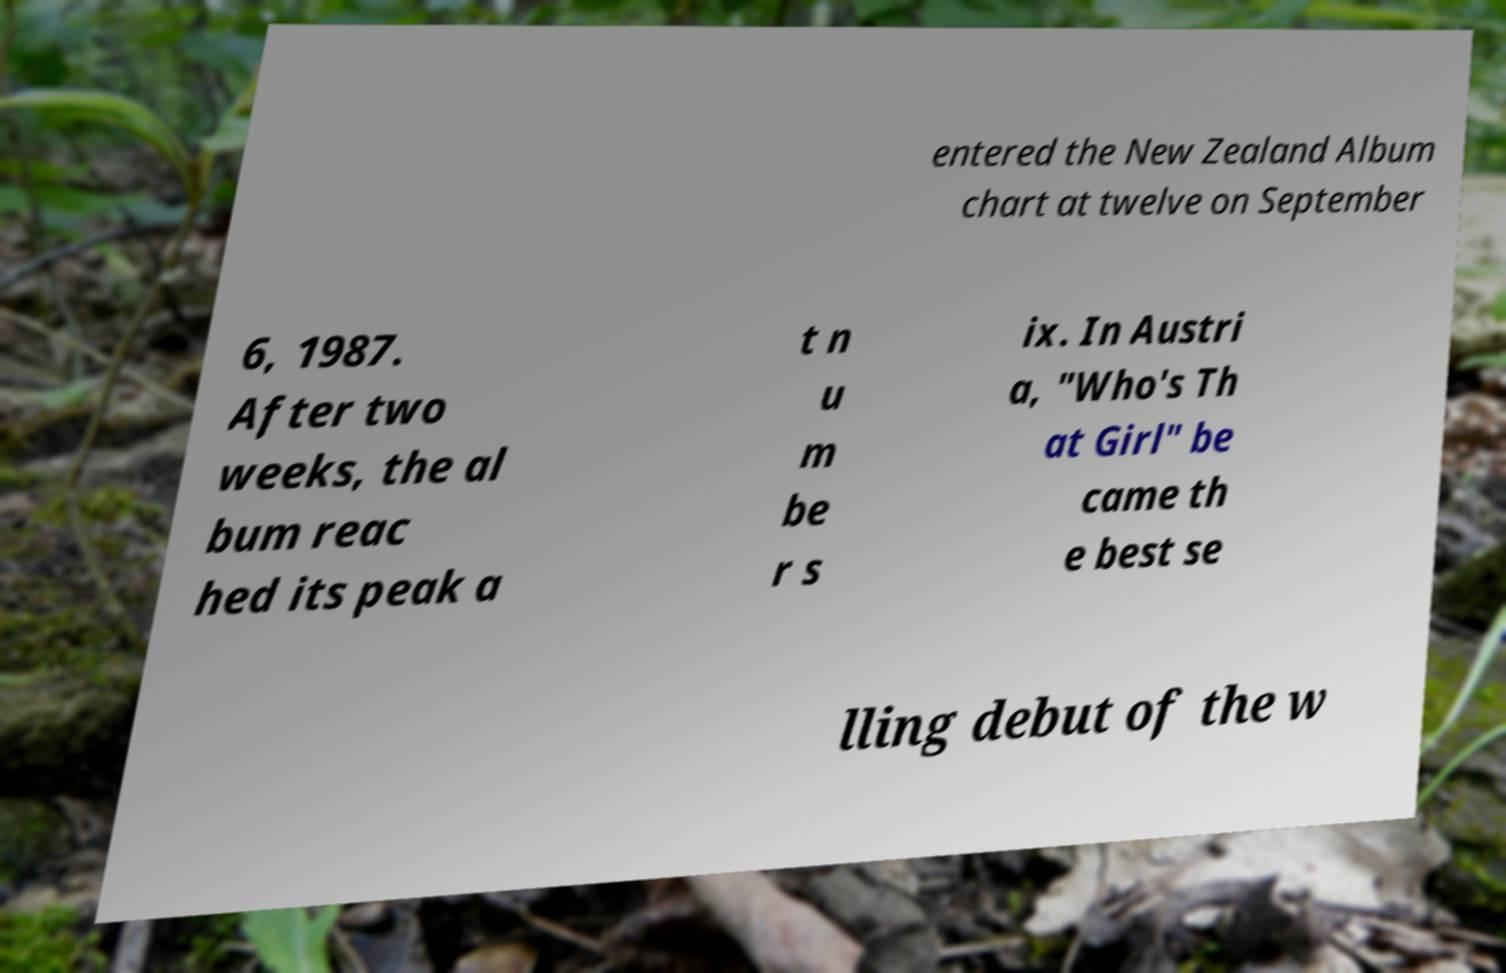Could you extract and type out the text from this image? entered the New Zealand Album chart at twelve on September 6, 1987. After two weeks, the al bum reac hed its peak a t n u m be r s ix. In Austri a, "Who's Th at Girl" be came th e best se lling debut of the w 